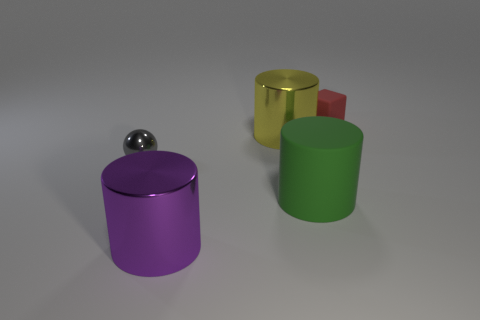Subtract all gray cylinders. Subtract all green balls. How many cylinders are left? 3 Add 2 metallic things. How many objects exist? 7 Subtract all blocks. How many objects are left? 4 Add 2 green cylinders. How many green cylinders are left? 3 Add 5 yellow metallic cylinders. How many yellow metallic cylinders exist? 6 Subtract 0 red cylinders. How many objects are left? 5 Subtract all big red shiny things. Subtract all gray things. How many objects are left? 4 